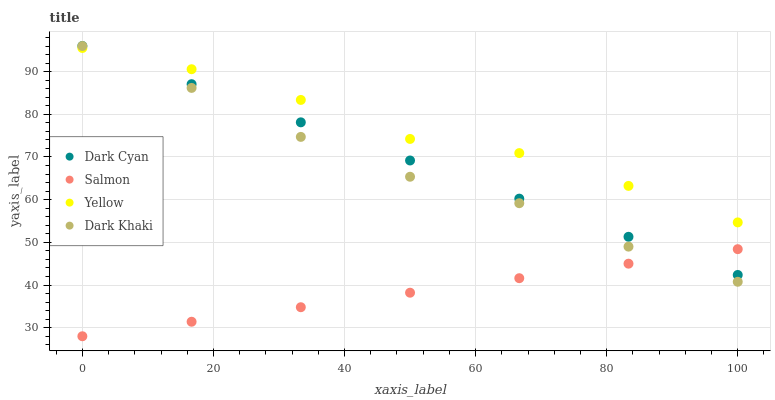Does Salmon have the minimum area under the curve?
Answer yes or no. Yes. Does Yellow have the maximum area under the curve?
Answer yes or no. Yes. Does Dark Khaki have the minimum area under the curve?
Answer yes or no. No. Does Dark Khaki have the maximum area under the curve?
Answer yes or no. No. Is Salmon the smoothest?
Answer yes or no. Yes. Is Yellow the roughest?
Answer yes or no. Yes. Is Dark Khaki the smoothest?
Answer yes or no. No. Is Dark Khaki the roughest?
Answer yes or no. No. Does Salmon have the lowest value?
Answer yes or no. Yes. Does Dark Khaki have the lowest value?
Answer yes or no. No. Does Dark Khaki have the highest value?
Answer yes or no. Yes. Does Salmon have the highest value?
Answer yes or no. No. Is Salmon less than Yellow?
Answer yes or no. Yes. Is Yellow greater than Salmon?
Answer yes or no. Yes. Does Dark Khaki intersect Yellow?
Answer yes or no. Yes. Is Dark Khaki less than Yellow?
Answer yes or no. No. Is Dark Khaki greater than Yellow?
Answer yes or no. No. Does Salmon intersect Yellow?
Answer yes or no. No. 